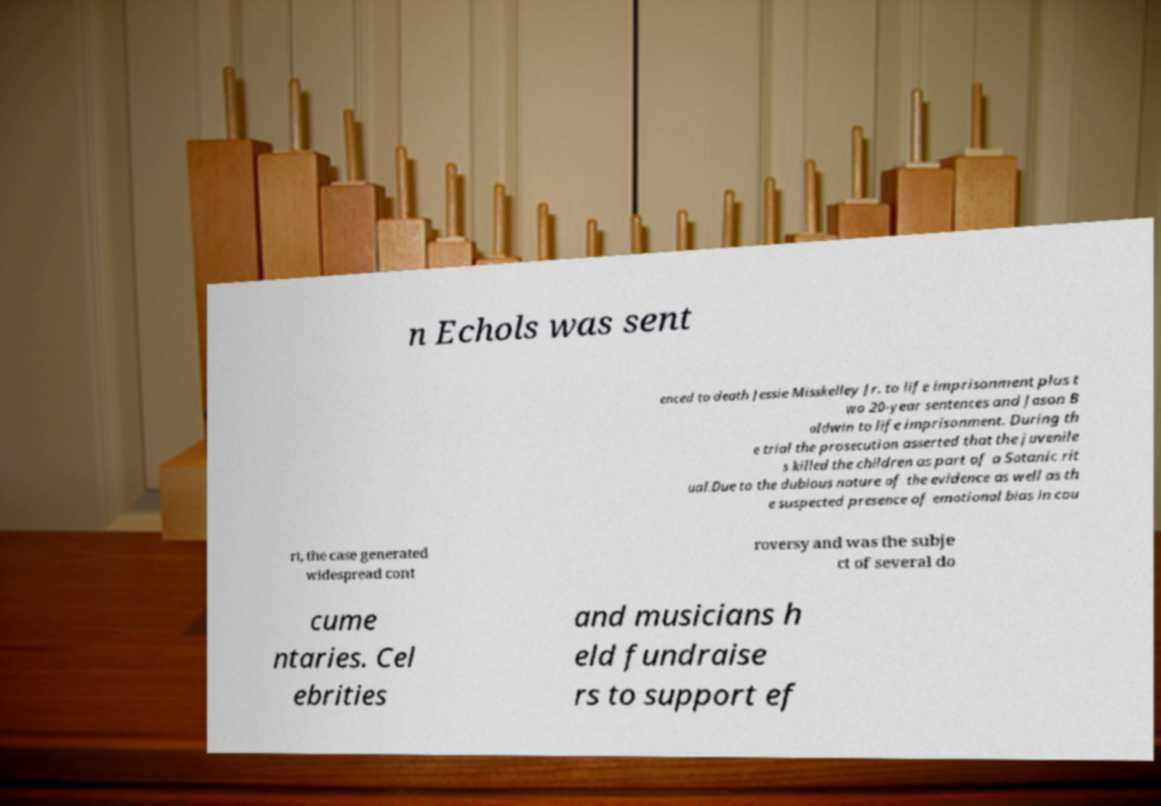Can you accurately transcribe the text from the provided image for me? n Echols was sent enced to death Jessie Misskelley Jr. to life imprisonment plus t wo 20-year sentences and Jason B aldwin to life imprisonment. During th e trial the prosecution asserted that the juvenile s killed the children as part of a Satanic rit ual.Due to the dubious nature of the evidence as well as th e suspected presence of emotional bias in cou rt, the case generated widespread cont roversy and was the subje ct of several do cume ntaries. Cel ebrities and musicians h eld fundraise rs to support ef 